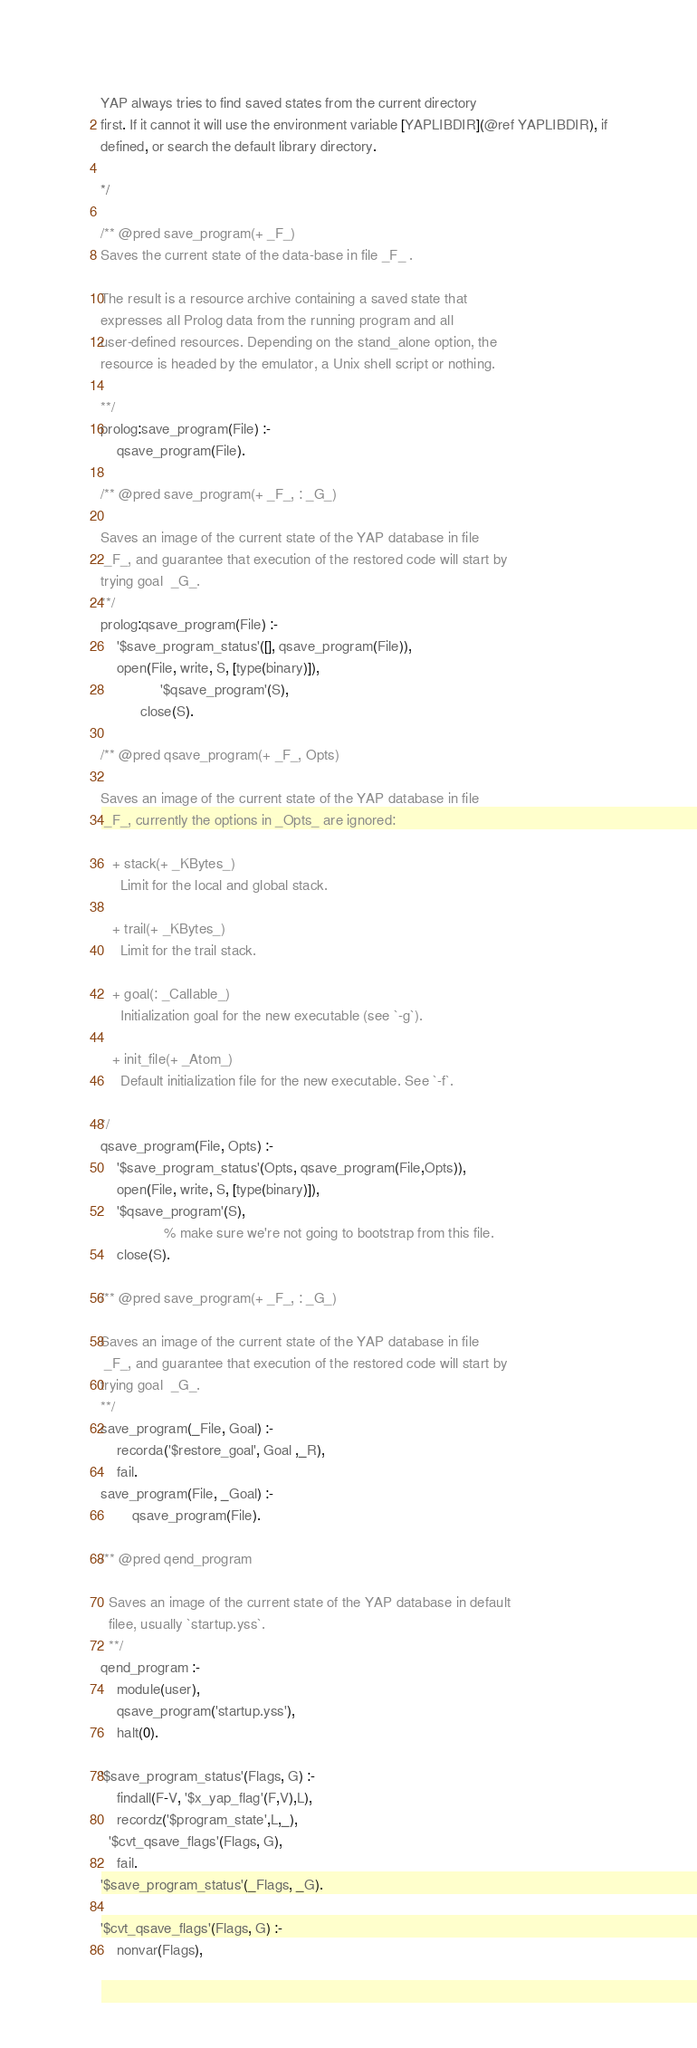<code> <loc_0><loc_0><loc_500><loc_500><_Prolog_>
YAP always tries to find saved states from the current directory
first. If it cannot it will use the environment variable [YAPLIBDIR](@ref YAPLIBDIR), if
defined, or search the default library directory.

*/

/** @pred save_program(+ _F_)
Saves the current state of the data-base in file _F_ .

The result is a resource archive containing a saved state that
expresses all Prolog data from the running program and all
user-defined resources. Depending on the stand_alone option, the
resource is headed by the emulator, a Unix shell script or nothing.

**/
prolog:save_program(File) :-
	qsave_program(File).

/** @pred save_program(+ _F_, : _G_)

Saves an image of the current state of the YAP database in file
 _F_, and guarantee that execution of the restored code will start by
trying goal  _G_.
**/
prolog:qsave_program(File) :-
    '$save_program_status'([], qsave_program(File)),
    open(File, write, S, [type(binary)]),
    	       '$qsave_program'(S),
		  close(S).

/** @pred qsave_program(+ _F_, Opts)

Saves an image of the current state of the YAP database in file
 _F_, currently the options in _Opts_ are ignored:

   + stack(+ _KBytes_)
     Limit for the local and global stack.

   + trail(+ _KBytes_)
     Limit for the trail stack.

   + goal(: _Callable_)
     Initialization goal for the new executable (see `-g`).

   + init_file(+ _Atom_)
     Default initialization file for the new executable. See `-f`.

*/
qsave_program(File, Opts) :-
    '$save_program_status'(Opts, qsave_program(File,Opts)),
    open(File, write, S, [type(binary)]),
    '$qsave_program'(S),
				% make sure we're not going to bootstrap from this file.
    close(S).

/** @pred save_program(+ _F_, : _G_)

Saves an image of the current state of the YAP database in file
 _F_, and guarantee that execution of the restored code will start by
trying goal  _G_.
**/
save_program(_File, Goal) :-
	recorda('$restore_goal', Goal ,_R),
	fail.
save_program(File, _Goal) :-
        qsave_program(File).

/** @pred qend_program

  Saves an image of the current state of the YAP database in default
  filee, usually `startup.yss`.
  **/
qend_program :-
	module(user),
	qsave_program('startup.yss'),
	halt(0).

'$save_program_status'(Flags, G) :-
    findall(F-V, '$x_yap_flag'(F,V),L),
    recordz('$program_state',L,_),
  '$cvt_qsave_flags'(Flags, G),
    fail.
'$save_program_status'(_Flags, _G).

'$cvt_qsave_flags'(Flags, G) :-
    nonvar(Flags),</code> 